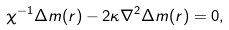Convert formula to latex. <formula><loc_0><loc_0><loc_500><loc_500>\chi ^ { - 1 } \Delta m ( r ) - 2 \kappa \nabla ^ { 2 } \Delta m ( r ) = 0 ,</formula> 